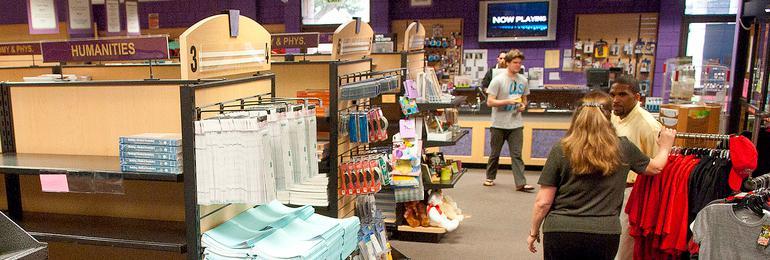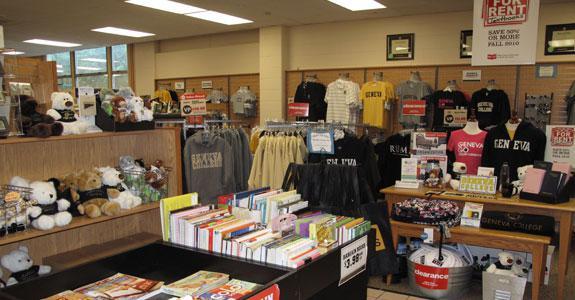The first image is the image on the left, the second image is the image on the right. For the images shown, is this caption "A woman in the image on the left has her hand on a rack." true? Answer yes or no. Yes. 